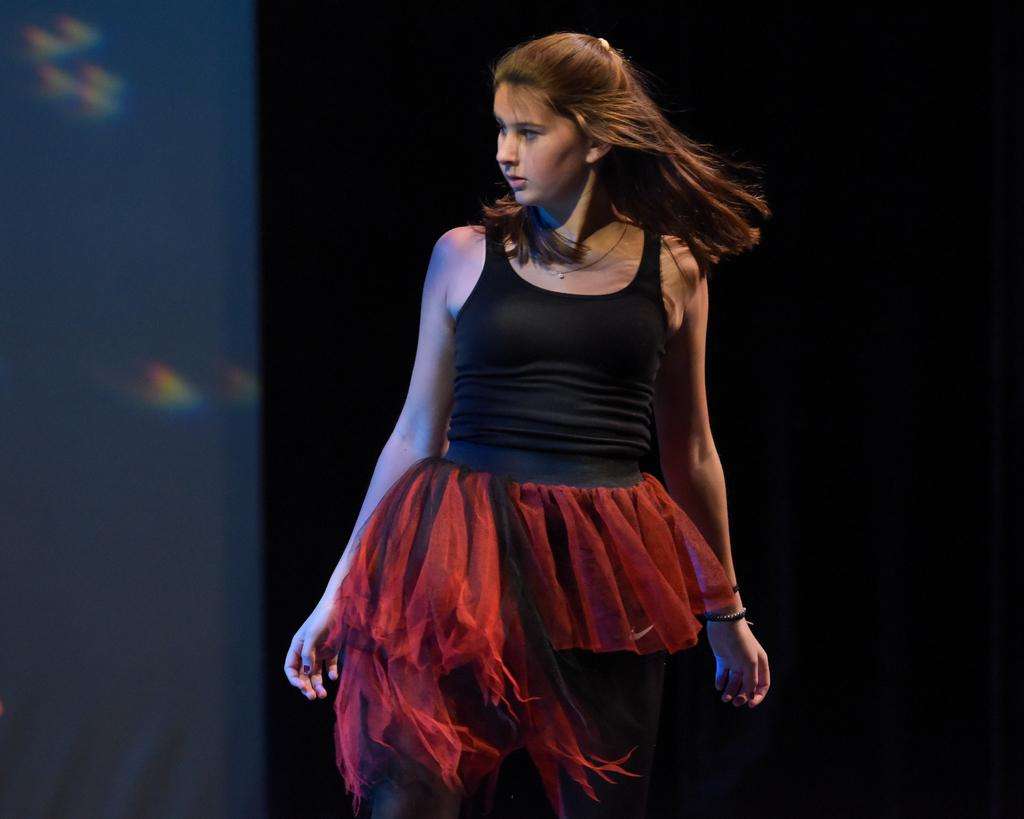Who is the main subject in the image? There is a woman in the image. What color is the background of the image? The background of the image is black. What degree does the woman hold in the image? There is no information about the woman's degree in the image. How hot is the environment in the image? The image does not provide any information about the temperature or heat in the environment. 